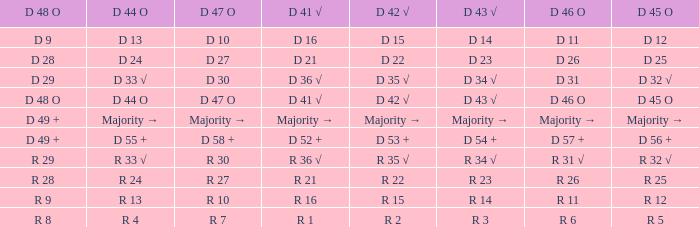Name the D 41 √ with D 44 O of r 13 R 16. 